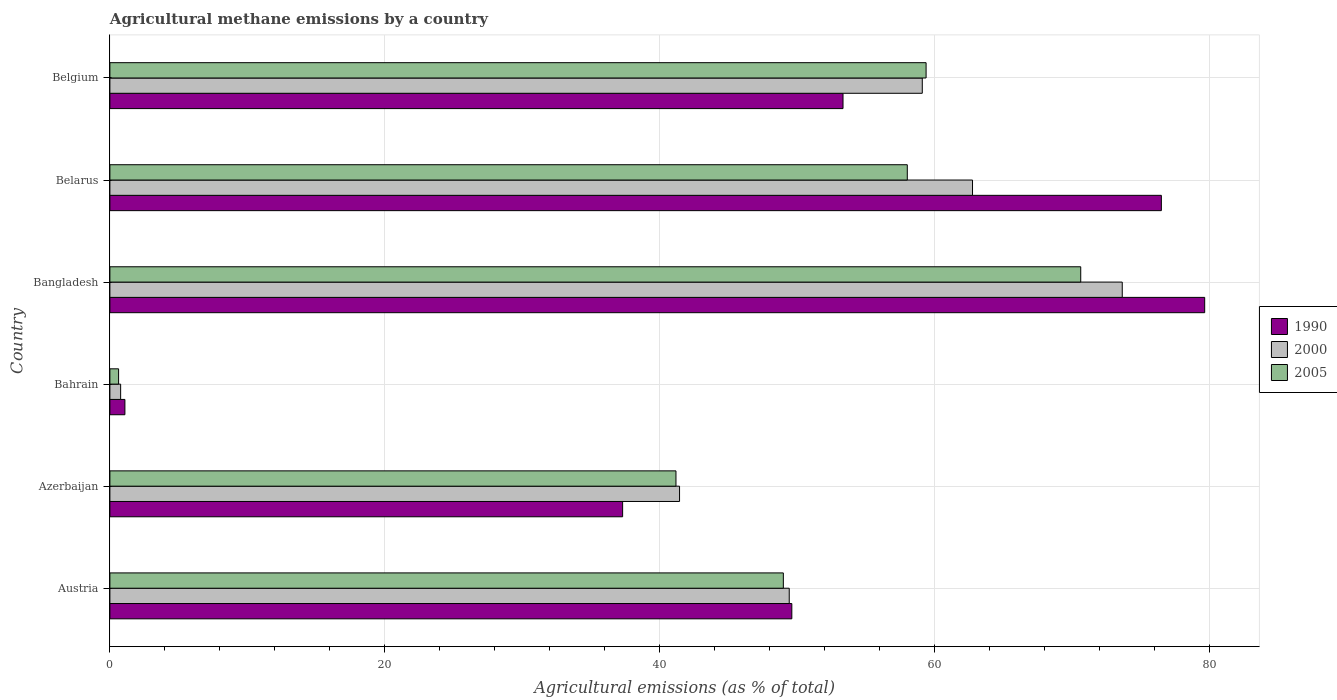What is the amount of agricultural methane emitted in 2000 in Belgium?
Your answer should be very brief. 59.1. Across all countries, what is the maximum amount of agricultural methane emitted in 2005?
Your response must be concise. 70.62. Across all countries, what is the minimum amount of agricultural methane emitted in 2005?
Offer a terse response. 0.63. In which country was the amount of agricultural methane emitted in 2005 maximum?
Your response must be concise. Bangladesh. In which country was the amount of agricultural methane emitted in 1990 minimum?
Keep it short and to the point. Bahrain. What is the total amount of agricultural methane emitted in 1990 in the graph?
Offer a terse response. 297.45. What is the difference between the amount of agricultural methane emitted in 1990 in Belarus and that in Belgium?
Your answer should be very brief. 23.16. What is the difference between the amount of agricultural methane emitted in 2005 in Belarus and the amount of agricultural methane emitted in 1990 in Austria?
Your response must be concise. 8.4. What is the average amount of agricultural methane emitted in 2005 per country?
Make the answer very short. 46.47. What is the difference between the amount of agricultural methane emitted in 2005 and amount of agricultural methane emitted in 2000 in Bangladesh?
Your answer should be compact. -3.02. What is the ratio of the amount of agricultural methane emitted in 2000 in Azerbaijan to that in Belgium?
Your response must be concise. 0.7. Is the amount of agricultural methane emitted in 2000 in Austria less than that in Bangladesh?
Provide a short and direct response. Yes. Is the difference between the amount of agricultural methane emitted in 2005 in Bangladesh and Belarus greater than the difference between the amount of agricultural methane emitted in 2000 in Bangladesh and Belarus?
Provide a short and direct response. Yes. What is the difference between the highest and the second highest amount of agricultural methane emitted in 2005?
Offer a terse response. 11.25. What is the difference between the highest and the lowest amount of agricultural methane emitted in 2005?
Your response must be concise. 69.99. In how many countries, is the amount of agricultural methane emitted in 2000 greater than the average amount of agricultural methane emitted in 2000 taken over all countries?
Keep it short and to the point. 4. Is the sum of the amount of agricultural methane emitted in 1990 in Austria and Azerbaijan greater than the maximum amount of agricultural methane emitted in 2005 across all countries?
Your answer should be compact. Yes. What does the 3rd bar from the top in Bahrain represents?
Your answer should be compact. 1990. What does the 2nd bar from the bottom in Azerbaijan represents?
Give a very brief answer. 2000. Is it the case that in every country, the sum of the amount of agricultural methane emitted in 1990 and amount of agricultural methane emitted in 2005 is greater than the amount of agricultural methane emitted in 2000?
Provide a short and direct response. Yes. How many bars are there?
Make the answer very short. 18. Are all the bars in the graph horizontal?
Give a very brief answer. Yes. How many countries are there in the graph?
Your answer should be very brief. 6. Are the values on the major ticks of X-axis written in scientific E-notation?
Give a very brief answer. No. Does the graph contain any zero values?
Make the answer very short. No. Does the graph contain grids?
Your response must be concise. Yes. What is the title of the graph?
Keep it short and to the point. Agricultural methane emissions by a country. What is the label or title of the X-axis?
Offer a terse response. Agricultural emissions (as % of total). What is the label or title of the Y-axis?
Your response must be concise. Country. What is the Agricultural emissions (as % of total) of 1990 in Austria?
Provide a succinct answer. 49.61. What is the Agricultural emissions (as % of total) in 2000 in Austria?
Provide a succinct answer. 49.42. What is the Agricultural emissions (as % of total) of 2005 in Austria?
Your answer should be compact. 48.99. What is the Agricultural emissions (as % of total) of 1990 in Azerbaijan?
Keep it short and to the point. 37.3. What is the Agricultural emissions (as % of total) in 2000 in Azerbaijan?
Offer a very short reply. 41.44. What is the Agricultural emissions (as % of total) in 2005 in Azerbaijan?
Provide a short and direct response. 41.18. What is the Agricultural emissions (as % of total) of 1990 in Bahrain?
Offer a terse response. 1.09. What is the Agricultural emissions (as % of total) of 2000 in Bahrain?
Provide a short and direct response. 0.78. What is the Agricultural emissions (as % of total) of 2005 in Bahrain?
Offer a very short reply. 0.63. What is the Agricultural emissions (as % of total) in 1990 in Bangladesh?
Ensure brevity in your answer.  79.64. What is the Agricultural emissions (as % of total) of 2000 in Bangladesh?
Offer a terse response. 73.64. What is the Agricultural emissions (as % of total) in 2005 in Bangladesh?
Your answer should be compact. 70.62. What is the Agricultural emissions (as % of total) of 1990 in Belarus?
Keep it short and to the point. 76.49. What is the Agricultural emissions (as % of total) in 2000 in Belarus?
Your response must be concise. 62.75. What is the Agricultural emissions (as % of total) of 2005 in Belarus?
Provide a short and direct response. 58.01. What is the Agricultural emissions (as % of total) in 1990 in Belgium?
Make the answer very short. 53.33. What is the Agricultural emissions (as % of total) of 2000 in Belgium?
Keep it short and to the point. 59.1. What is the Agricultural emissions (as % of total) in 2005 in Belgium?
Offer a very short reply. 59.37. Across all countries, what is the maximum Agricultural emissions (as % of total) of 1990?
Provide a short and direct response. 79.64. Across all countries, what is the maximum Agricultural emissions (as % of total) in 2000?
Your response must be concise. 73.64. Across all countries, what is the maximum Agricultural emissions (as % of total) in 2005?
Give a very brief answer. 70.62. Across all countries, what is the minimum Agricultural emissions (as % of total) in 1990?
Provide a short and direct response. 1.09. Across all countries, what is the minimum Agricultural emissions (as % of total) in 2000?
Offer a very short reply. 0.78. Across all countries, what is the minimum Agricultural emissions (as % of total) in 2005?
Your answer should be compact. 0.63. What is the total Agricultural emissions (as % of total) in 1990 in the graph?
Make the answer very short. 297.45. What is the total Agricultural emissions (as % of total) in 2000 in the graph?
Offer a terse response. 287.13. What is the total Agricultural emissions (as % of total) of 2005 in the graph?
Make the answer very short. 278.8. What is the difference between the Agricultural emissions (as % of total) of 1990 in Austria and that in Azerbaijan?
Give a very brief answer. 12.31. What is the difference between the Agricultural emissions (as % of total) of 2000 in Austria and that in Azerbaijan?
Ensure brevity in your answer.  7.98. What is the difference between the Agricultural emissions (as % of total) in 2005 in Austria and that in Azerbaijan?
Provide a succinct answer. 7.81. What is the difference between the Agricultural emissions (as % of total) of 1990 in Austria and that in Bahrain?
Provide a succinct answer. 48.51. What is the difference between the Agricultural emissions (as % of total) of 2000 in Austria and that in Bahrain?
Make the answer very short. 48.64. What is the difference between the Agricultural emissions (as % of total) of 2005 in Austria and that in Bahrain?
Make the answer very short. 48.36. What is the difference between the Agricultural emissions (as % of total) in 1990 in Austria and that in Bangladesh?
Give a very brief answer. -30.03. What is the difference between the Agricultural emissions (as % of total) in 2000 in Austria and that in Bangladesh?
Give a very brief answer. -24.23. What is the difference between the Agricultural emissions (as % of total) of 2005 in Austria and that in Bangladesh?
Make the answer very short. -21.63. What is the difference between the Agricultural emissions (as % of total) in 1990 in Austria and that in Belarus?
Offer a very short reply. -26.88. What is the difference between the Agricultural emissions (as % of total) in 2000 in Austria and that in Belarus?
Provide a short and direct response. -13.33. What is the difference between the Agricultural emissions (as % of total) of 2005 in Austria and that in Belarus?
Offer a terse response. -9.02. What is the difference between the Agricultural emissions (as % of total) of 1990 in Austria and that in Belgium?
Provide a succinct answer. -3.72. What is the difference between the Agricultural emissions (as % of total) in 2000 in Austria and that in Belgium?
Your response must be concise. -9.68. What is the difference between the Agricultural emissions (as % of total) of 2005 in Austria and that in Belgium?
Keep it short and to the point. -10.38. What is the difference between the Agricultural emissions (as % of total) of 1990 in Azerbaijan and that in Bahrain?
Offer a very short reply. 36.21. What is the difference between the Agricultural emissions (as % of total) of 2000 in Azerbaijan and that in Bahrain?
Provide a short and direct response. 40.66. What is the difference between the Agricultural emissions (as % of total) of 2005 in Azerbaijan and that in Bahrain?
Your answer should be compact. 40.54. What is the difference between the Agricultural emissions (as % of total) of 1990 in Azerbaijan and that in Bangladesh?
Make the answer very short. -42.34. What is the difference between the Agricultural emissions (as % of total) in 2000 in Azerbaijan and that in Bangladesh?
Provide a succinct answer. -32.2. What is the difference between the Agricultural emissions (as % of total) of 2005 in Azerbaijan and that in Bangladesh?
Your response must be concise. -29.44. What is the difference between the Agricultural emissions (as % of total) in 1990 in Azerbaijan and that in Belarus?
Ensure brevity in your answer.  -39.19. What is the difference between the Agricultural emissions (as % of total) of 2000 in Azerbaijan and that in Belarus?
Make the answer very short. -21.31. What is the difference between the Agricultural emissions (as % of total) of 2005 in Azerbaijan and that in Belarus?
Keep it short and to the point. -16.83. What is the difference between the Agricultural emissions (as % of total) of 1990 in Azerbaijan and that in Belgium?
Offer a terse response. -16.03. What is the difference between the Agricultural emissions (as % of total) of 2000 in Azerbaijan and that in Belgium?
Ensure brevity in your answer.  -17.66. What is the difference between the Agricultural emissions (as % of total) in 2005 in Azerbaijan and that in Belgium?
Ensure brevity in your answer.  -18.2. What is the difference between the Agricultural emissions (as % of total) in 1990 in Bahrain and that in Bangladesh?
Your response must be concise. -78.55. What is the difference between the Agricultural emissions (as % of total) of 2000 in Bahrain and that in Bangladesh?
Provide a short and direct response. -72.86. What is the difference between the Agricultural emissions (as % of total) of 2005 in Bahrain and that in Bangladesh?
Give a very brief answer. -69.99. What is the difference between the Agricultural emissions (as % of total) of 1990 in Bahrain and that in Belarus?
Provide a succinct answer. -75.4. What is the difference between the Agricultural emissions (as % of total) of 2000 in Bahrain and that in Belarus?
Make the answer very short. -61.97. What is the difference between the Agricultural emissions (as % of total) in 2005 in Bahrain and that in Belarus?
Your response must be concise. -57.37. What is the difference between the Agricultural emissions (as % of total) in 1990 in Bahrain and that in Belgium?
Offer a very short reply. -52.24. What is the difference between the Agricultural emissions (as % of total) in 2000 in Bahrain and that in Belgium?
Your answer should be compact. -58.31. What is the difference between the Agricultural emissions (as % of total) in 2005 in Bahrain and that in Belgium?
Your response must be concise. -58.74. What is the difference between the Agricultural emissions (as % of total) of 1990 in Bangladesh and that in Belarus?
Your response must be concise. 3.15. What is the difference between the Agricultural emissions (as % of total) in 2000 in Bangladesh and that in Belarus?
Make the answer very short. 10.89. What is the difference between the Agricultural emissions (as % of total) in 2005 in Bangladesh and that in Belarus?
Provide a short and direct response. 12.62. What is the difference between the Agricultural emissions (as % of total) of 1990 in Bangladesh and that in Belgium?
Ensure brevity in your answer.  26.31. What is the difference between the Agricultural emissions (as % of total) of 2000 in Bangladesh and that in Belgium?
Provide a short and direct response. 14.55. What is the difference between the Agricultural emissions (as % of total) of 2005 in Bangladesh and that in Belgium?
Your answer should be very brief. 11.25. What is the difference between the Agricultural emissions (as % of total) of 1990 in Belarus and that in Belgium?
Keep it short and to the point. 23.16. What is the difference between the Agricultural emissions (as % of total) in 2000 in Belarus and that in Belgium?
Ensure brevity in your answer.  3.65. What is the difference between the Agricultural emissions (as % of total) in 2005 in Belarus and that in Belgium?
Offer a terse response. -1.37. What is the difference between the Agricultural emissions (as % of total) of 1990 in Austria and the Agricultural emissions (as % of total) of 2000 in Azerbaijan?
Provide a succinct answer. 8.17. What is the difference between the Agricultural emissions (as % of total) in 1990 in Austria and the Agricultural emissions (as % of total) in 2005 in Azerbaijan?
Provide a short and direct response. 8.43. What is the difference between the Agricultural emissions (as % of total) in 2000 in Austria and the Agricultural emissions (as % of total) in 2005 in Azerbaijan?
Your response must be concise. 8.24. What is the difference between the Agricultural emissions (as % of total) in 1990 in Austria and the Agricultural emissions (as % of total) in 2000 in Bahrain?
Your response must be concise. 48.82. What is the difference between the Agricultural emissions (as % of total) in 1990 in Austria and the Agricultural emissions (as % of total) in 2005 in Bahrain?
Make the answer very short. 48.97. What is the difference between the Agricultural emissions (as % of total) in 2000 in Austria and the Agricultural emissions (as % of total) in 2005 in Bahrain?
Provide a succinct answer. 48.78. What is the difference between the Agricultural emissions (as % of total) in 1990 in Austria and the Agricultural emissions (as % of total) in 2000 in Bangladesh?
Make the answer very short. -24.04. What is the difference between the Agricultural emissions (as % of total) of 1990 in Austria and the Agricultural emissions (as % of total) of 2005 in Bangladesh?
Your response must be concise. -21.02. What is the difference between the Agricultural emissions (as % of total) in 2000 in Austria and the Agricultural emissions (as % of total) in 2005 in Bangladesh?
Offer a terse response. -21.2. What is the difference between the Agricultural emissions (as % of total) of 1990 in Austria and the Agricultural emissions (as % of total) of 2000 in Belarus?
Offer a very short reply. -13.14. What is the difference between the Agricultural emissions (as % of total) in 1990 in Austria and the Agricultural emissions (as % of total) in 2005 in Belarus?
Keep it short and to the point. -8.4. What is the difference between the Agricultural emissions (as % of total) in 2000 in Austria and the Agricultural emissions (as % of total) in 2005 in Belarus?
Your answer should be very brief. -8.59. What is the difference between the Agricultural emissions (as % of total) in 1990 in Austria and the Agricultural emissions (as % of total) in 2000 in Belgium?
Your response must be concise. -9.49. What is the difference between the Agricultural emissions (as % of total) of 1990 in Austria and the Agricultural emissions (as % of total) of 2005 in Belgium?
Your answer should be compact. -9.77. What is the difference between the Agricultural emissions (as % of total) of 2000 in Austria and the Agricultural emissions (as % of total) of 2005 in Belgium?
Keep it short and to the point. -9.96. What is the difference between the Agricultural emissions (as % of total) in 1990 in Azerbaijan and the Agricultural emissions (as % of total) in 2000 in Bahrain?
Your answer should be very brief. 36.52. What is the difference between the Agricultural emissions (as % of total) of 1990 in Azerbaijan and the Agricultural emissions (as % of total) of 2005 in Bahrain?
Your answer should be compact. 36.66. What is the difference between the Agricultural emissions (as % of total) in 2000 in Azerbaijan and the Agricultural emissions (as % of total) in 2005 in Bahrain?
Offer a terse response. 40.8. What is the difference between the Agricultural emissions (as % of total) in 1990 in Azerbaijan and the Agricultural emissions (as % of total) in 2000 in Bangladesh?
Make the answer very short. -36.34. What is the difference between the Agricultural emissions (as % of total) in 1990 in Azerbaijan and the Agricultural emissions (as % of total) in 2005 in Bangladesh?
Give a very brief answer. -33.32. What is the difference between the Agricultural emissions (as % of total) in 2000 in Azerbaijan and the Agricultural emissions (as % of total) in 2005 in Bangladesh?
Ensure brevity in your answer.  -29.18. What is the difference between the Agricultural emissions (as % of total) in 1990 in Azerbaijan and the Agricultural emissions (as % of total) in 2000 in Belarus?
Keep it short and to the point. -25.45. What is the difference between the Agricultural emissions (as % of total) in 1990 in Azerbaijan and the Agricultural emissions (as % of total) in 2005 in Belarus?
Offer a very short reply. -20.71. What is the difference between the Agricultural emissions (as % of total) in 2000 in Azerbaijan and the Agricultural emissions (as % of total) in 2005 in Belarus?
Offer a terse response. -16.57. What is the difference between the Agricultural emissions (as % of total) in 1990 in Azerbaijan and the Agricultural emissions (as % of total) in 2000 in Belgium?
Offer a very short reply. -21.8. What is the difference between the Agricultural emissions (as % of total) of 1990 in Azerbaijan and the Agricultural emissions (as % of total) of 2005 in Belgium?
Provide a succinct answer. -22.08. What is the difference between the Agricultural emissions (as % of total) of 2000 in Azerbaijan and the Agricultural emissions (as % of total) of 2005 in Belgium?
Your answer should be very brief. -17.93. What is the difference between the Agricultural emissions (as % of total) in 1990 in Bahrain and the Agricultural emissions (as % of total) in 2000 in Bangladesh?
Provide a short and direct response. -72.55. What is the difference between the Agricultural emissions (as % of total) in 1990 in Bahrain and the Agricultural emissions (as % of total) in 2005 in Bangladesh?
Keep it short and to the point. -69.53. What is the difference between the Agricultural emissions (as % of total) of 2000 in Bahrain and the Agricultural emissions (as % of total) of 2005 in Bangladesh?
Your answer should be compact. -69.84. What is the difference between the Agricultural emissions (as % of total) of 1990 in Bahrain and the Agricultural emissions (as % of total) of 2000 in Belarus?
Offer a very short reply. -61.66. What is the difference between the Agricultural emissions (as % of total) in 1990 in Bahrain and the Agricultural emissions (as % of total) in 2005 in Belarus?
Your answer should be compact. -56.91. What is the difference between the Agricultural emissions (as % of total) of 2000 in Bahrain and the Agricultural emissions (as % of total) of 2005 in Belarus?
Ensure brevity in your answer.  -57.22. What is the difference between the Agricultural emissions (as % of total) in 1990 in Bahrain and the Agricultural emissions (as % of total) in 2000 in Belgium?
Offer a very short reply. -58. What is the difference between the Agricultural emissions (as % of total) of 1990 in Bahrain and the Agricultural emissions (as % of total) of 2005 in Belgium?
Keep it short and to the point. -58.28. What is the difference between the Agricultural emissions (as % of total) in 2000 in Bahrain and the Agricultural emissions (as % of total) in 2005 in Belgium?
Your answer should be very brief. -58.59. What is the difference between the Agricultural emissions (as % of total) of 1990 in Bangladesh and the Agricultural emissions (as % of total) of 2000 in Belarus?
Ensure brevity in your answer.  16.89. What is the difference between the Agricultural emissions (as % of total) of 1990 in Bangladesh and the Agricultural emissions (as % of total) of 2005 in Belarus?
Provide a succinct answer. 21.63. What is the difference between the Agricultural emissions (as % of total) of 2000 in Bangladesh and the Agricultural emissions (as % of total) of 2005 in Belarus?
Your response must be concise. 15.64. What is the difference between the Agricultural emissions (as % of total) of 1990 in Bangladesh and the Agricultural emissions (as % of total) of 2000 in Belgium?
Make the answer very short. 20.54. What is the difference between the Agricultural emissions (as % of total) of 1990 in Bangladesh and the Agricultural emissions (as % of total) of 2005 in Belgium?
Your response must be concise. 20.27. What is the difference between the Agricultural emissions (as % of total) in 2000 in Bangladesh and the Agricultural emissions (as % of total) in 2005 in Belgium?
Your answer should be very brief. 14.27. What is the difference between the Agricultural emissions (as % of total) in 1990 in Belarus and the Agricultural emissions (as % of total) in 2000 in Belgium?
Your answer should be compact. 17.39. What is the difference between the Agricultural emissions (as % of total) of 1990 in Belarus and the Agricultural emissions (as % of total) of 2005 in Belgium?
Your answer should be compact. 17.11. What is the difference between the Agricultural emissions (as % of total) in 2000 in Belarus and the Agricultural emissions (as % of total) in 2005 in Belgium?
Your response must be concise. 3.38. What is the average Agricultural emissions (as % of total) in 1990 per country?
Ensure brevity in your answer.  49.58. What is the average Agricultural emissions (as % of total) in 2000 per country?
Give a very brief answer. 47.85. What is the average Agricultural emissions (as % of total) of 2005 per country?
Make the answer very short. 46.47. What is the difference between the Agricultural emissions (as % of total) in 1990 and Agricultural emissions (as % of total) in 2000 in Austria?
Make the answer very short. 0.19. What is the difference between the Agricultural emissions (as % of total) in 1990 and Agricultural emissions (as % of total) in 2005 in Austria?
Your answer should be very brief. 0.62. What is the difference between the Agricultural emissions (as % of total) in 2000 and Agricultural emissions (as % of total) in 2005 in Austria?
Ensure brevity in your answer.  0.43. What is the difference between the Agricultural emissions (as % of total) in 1990 and Agricultural emissions (as % of total) in 2000 in Azerbaijan?
Make the answer very short. -4.14. What is the difference between the Agricultural emissions (as % of total) of 1990 and Agricultural emissions (as % of total) of 2005 in Azerbaijan?
Give a very brief answer. -3.88. What is the difference between the Agricultural emissions (as % of total) in 2000 and Agricultural emissions (as % of total) in 2005 in Azerbaijan?
Ensure brevity in your answer.  0.26. What is the difference between the Agricultural emissions (as % of total) in 1990 and Agricultural emissions (as % of total) in 2000 in Bahrain?
Ensure brevity in your answer.  0.31. What is the difference between the Agricultural emissions (as % of total) of 1990 and Agricultural emissions (as % of total) of 2005 in Bahrain?
Your answer should be compact. 0.46. What is the difference between the Agricultural emissions (as % of total) in 2000 and Agricultural emissions (as % of total) in 2005 in Bahrain?
Provide a succinct answer. 0.15. What is the difference between the Agricultural emissions (as % of total) in 1990 and Agricultural emissions (as % of total) in 2000 in Bangladesh?
Keep it short and to the point. 6. What is the difference between the Agricultural emissions (as % of total) in 1990 and Agricultural emissions (as % of total) in 2005 in Bangladesh?
Make the answer very short. 9.02. What is the difference between the Agricultural emissions (as % of total) of 2000 and Agricultural emissions (as % of total) of 2005 in Bangladesh?
Your answer should be very brief. 3.02. What is the difference between the Agricultural emissions (as % of total) in 1990 and Agricultural emissions (as % of total) in 2000 in Belarus?
Your answer should be compact. 13.74. What is the difference between the Agricultural emissions (as % of total) of 1990 and Agricultural emissions (as % of total) of 2005 in Belarus?
Your answer should be very brief. 18.48. What is the difference between the Agricultural emissions (as % of total) in 2000 and Agricultural emissions (as % of total) in 2005 in Belarus?
Keep it short and to the point. 4.74. What is the difference between the Agricultural emissions (as % of total) of 1990 and Agricultural emissions (as % of total) of 2000 in Belgium?
Keep it short and to the point. -5.77. What is the difference between the Agricultural emissions (as % of total) of 1990 and Agricultural emissions (as % of total) of 2005 in Belgium?
Offer a terse response. -6.04. What is the difference between the Agricultural emissions (as % of total) of 2000 and Agricultural emissions (as % of total) of 2005 in Belgium?
Give a very brief answer. -0.28. What is the ratio of the Agricultural emissions (as % of total) of 1990 in Austria to that in Azerbaijan?
Your answer should be compact. 1.33. What is the ratio of the Agricultural emissions (as % of total) of 2000 in Austria to that in Azerbaijan?
Give a very brief answer. 1.19. What is the ratio of the Agricultural emissions (as % of total) of 2005 in Austria to that in Azerbaijan?
Keep it short and to the point. 1.19. What is the ratio of the Agricultural emissions (as % of total) of 1990 in Austria to that in Bahrain?
Provide a short and direct response. 45.42. What is the ratio of the Agricultural emissions (as % of total) of 2000 in Austria to that in Bahrain?
Keep it short and to the point. 63.21. What is the ratio of the Agricultural emissions (as % of total) in 2005 in Austria to that in Bahrain?
Provide a succinct answer. 77.32. What is the ratio of the Agricultural emissions (as % of total) in 1990 in Austria to that in Bangladesh?
Ensure brevity in your answer.  0.62. What is the ratio of the Agricultural emissions (as % of total) in 2000 in Austria to that in Bangladesh?
Your response must be concise. 0.67. What is the ratio of the Agricultural emissions (as % of total) in 2005 in Austria to that in Bangladesh?
Provide a short and direct response. 0.69. What is the ratio of the Agricultural emissions (as % of total) of 1990 in Austria to that in Belarus?
Give a very brief answer. 0.65. What is the ratio of the Agricultural emissions (as % of total) in 2000 in Austria to that in Belarus?
Your answer should be compact. 0.79. What is the ratio of the Agricultural emissions (as % of total) of 2005 in Austria to that in Belarus?
Your answer should be very brief. 0.84. What is the ratio of the Agricultural emissions (as % of total) in 1990 in Austria to that in Belgium?
Ensure brevity in your answer.  0.93. What is the ratio of the Agricultural emissions (as % of total) in 2000 in Austria to that in Belgium?
Ensure brevity in your answer.  0.84. What is the ratio of the Agricultural emissions (as % of total) of 2005 in Austria to that in Belgium?
Ensure brevity in your answer.  0.83. What is the ratio of the Agricultural emissions (as % of total) of 1990 in Azerbaijan to that in Bahrain?
Keep it short and to the point. 34.15. What is the ratio of the Agricultural emissions (as % of total) in 2000 in Azerbaijan to that in Bahrain?
Offer a very short reply. 53. What is the ratio of the Agricultural emissions (as % of total) in 2005 in Azerbaijan to that in Bahrain?
Your answer should be compact. 64.99. What is the ratio of the Agricultural emissions (as % of total) in 1990 in Azerbaijan to that in Bangladesh?
Your response must be concise. 0.47. What is the ratio of the Agricultural emissions (as % of total) in 2000 in Azerbaijan to that in Bangladesh?
Provide a short and direct response. 0.56. What is the ratio of the Agricultural emissions (as % of total) in 2005 in Azerbaijan to that in Bangladesh?
Provide a succinct answer. 0.58. What is the ratio of the Agricultural emissions (as % of total) of 1990 in Azerbaijan to that in Belarus?
Ensure brevity in your answer.  0.49. What is the ratio of the Agricultural emissions (as % of total) of 2000 in Azerbaijan to that in Belarus?
Your answer should be very brief. 0.66. What is the ratio of the Agricultural emissions (as % of total) in 2005 in Azerbaijan to that in Belarus?
Your answer should be compact. 0.71. What is the ratio of the Agricultural emissions (as % of total) in 1990 in Azerbaijan to that in Belgium?
Your response must be concise. 0.7. What is the ratio of the Agricultural emissions (as % of total) in 2000 in Azerbaijan to that in Belgium?
Offer a terse response. 0.7. What is the ratio of the Agricultural emissions (as % of total) of 2005 in Azerbaijan to that in Belgium?
Ensure brevity in your answer.  0.69. What is the ratio of the Agricultural emissions (as % of total) of 1990 in Bahrain to that in Bangladesh?
Provide a succinct answer. 0.01. What is the ratio of the Agricultural emissions (as % of total) in 2000 in Bahrain to that in Bangladesh?
Give a very brief answer. 0.01. What is the ratio of the Agricultural emissions (as % of total) in 2005 in Bahrain to that in Bangladesh?
Keep it short and to the point. 0.01. What is the ratio of the Agricultural emissions (as % of total) in 1990 in Bahrain to that in Belarus?
Offer a terse response. 0.01. What is the ratio of the Agricultural emissions (as % of total) of 2000 in Bahrain to that in Belarus?
Give a very brief answer. 0.01. What is the ratio of the Agricultural emissions (as % of total) in 2005 in Bahrain to that in Belarus?
Your answer should be compact. 0.01. What is the ratio of the Agricultural emissions (as % of total) in 1990 in Bahrain to that in Belgium?
Your answer should be very brief. 0.02. What is the ratio of the Agricultural emissions (as % of total) of 2000 in Bahrain to that in Belgium?
Offer a very short reply. 0.01. What is the ratio of the Agricultural emissions (as % of total) of 2005 in Bahrain to that in Belgium?
Provide a short and direct response. 0.01. What is the ratio of the Agricultural emissions (as % of total) in 1990 in Bangladesh to that in Belarus?
Offer a very short reply. 1.04. What is the ratio of the Agricultural emissions (as % of total) in 2000 in Bangladesh to that in Belarus?
Keep it short and to the point. 1.17. What is the ratio of the Agricultural emissions (as % of total) in 2005 in Bangladesh to that in Belarus?
Your answer should be very brief. 1.22. What is the ratio of the Agricultural emissions (as % of total) of 1990 in Bangladesh to that in Belgium?
Ensure brevity in your answer.  1.49. What is the ratio of the Agricultural emissions (as % of total) in 2000 in Bangladesh to that in Belgium?
Your answer should be compact. 1.25. What is the ratio of the Agricultural emissions (as % of total) in 2005 in Bangladesh to that in Belgium?
Keep it short and to the point. 1.19. What is the ratio of the Agricultural emissions (as % of total) of 1990 in Belarus to that in Belgium?
Offer a terse response. 1.43. What is the ratio of the Agricultural emissions (as % of total) in 2000 in Belarus to that in Belgium?
Offer a terse response. 1.06. What is the ratio of the Agricultural emissions (as % of total) of 2005 in Belarus to that in Belgium?
Offer a very short reply. 0.98. What is the difference between the highest and the second highest Agricultural emissions (as % of total) in 1990?
Offer a very short reply. 3.15. What is the difference between the highest and the second highest Agricultural emissions (as % of total) in 2000?
Offer a terse response. 10.89. What is the difference between the highest and the second highest Agricultural emissions (as % of total) of 2005?
Offer a very short reply. 11.25. What is the difference between the highest and the lowest Agricultural emissions (as % of total) of 1990?
Provide a succinct answer. 78.55. What is the difference between the highest and the lowest Agricultural emissions (as % of total) of 2000?
Provide a short and direct response. 72.86. What is the difference between the highest and the lowest Agricultural emissions (as % of total) of 2005?
Keep it short and to the point. 69.99. 